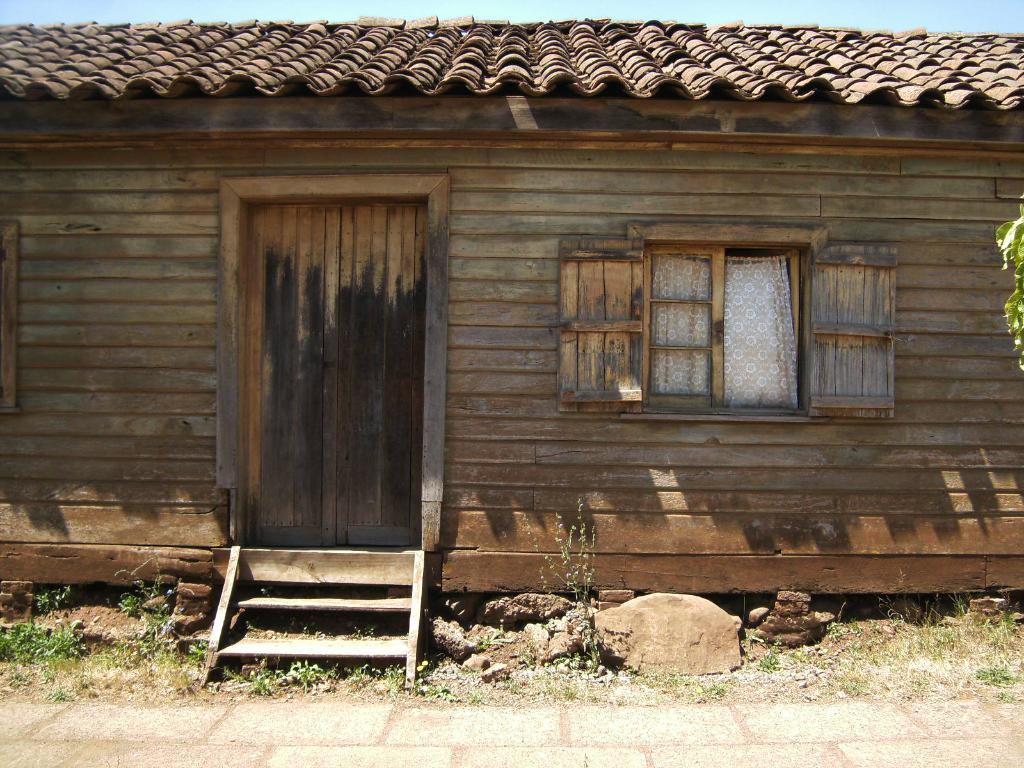How would you summarize this image in a sentence or two? This picture is taken from the outside of the house and it is sunny. In this image, in the middle, we can see a door, staircase. On the right side of the house, we can also see a window, in the window, we can see a curtain. At the top, we can see a roof and a sky, at the bottom, we can see some stones and a land. 